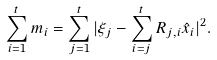Convert formula to latex. <formula><loc_0><loc_0><loc_500><loc_500>\sum _ { i = 1 } ^ { t } m _ { i } = \sum _ { j = 1 } ^ { t } | \xi _ { j } - \sum _ { i = j } ^ { t } R _ { j , i } \hat { x } _ { i } | ^ { 2 } .</formula> 